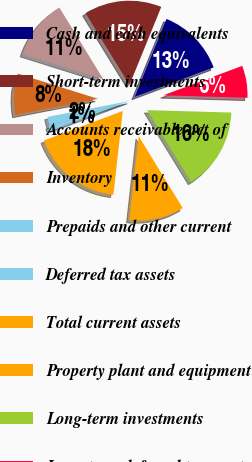<chart> <loc_0><loc_0><loc_500><loc_500><pie_chart><fcel>Cash and cash equivalents<fcel>Short-term investments<fcel>Accounts receivable net of<fcel>Inventory<fcel>Prepaids and other current<fcel>Deferred tax assets<fcel>Total current assets<fcel>Property plant and equipment<fcel>Long-term investments<fcel>Long-term deferred tax asset<nl><fcel>13.16%<fcel>14.91%<fcel>11.4%<fcel>7.9%<fcel>1.76%<fcel>0.88%<fcel>17.54%<fcel>10.53%<fcel>15.79%<fcel>6.14%<nl></chart> 